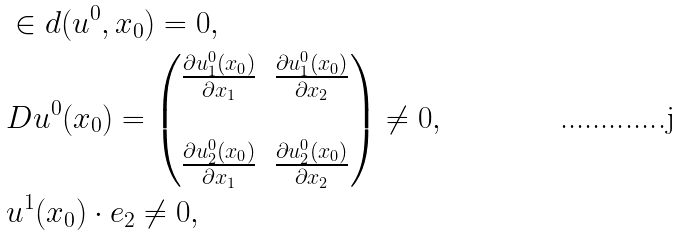<formula> <loc_0><loc_0><loc_500><loc_500>& \in d ( u ^ { 0 } , x _ { 0 } ) = 0 , \\ & D u ^ { 0 } ( x _ { 0 } ) = \left ( \begin{matrix} \frac { \partial u ^ { 0 } _ { 1 } ( x _ { 0 } ) } { \partial x _ { 1 } } & \frac { \partial u ^ { 0 } _ { 1 } ( x _ { 0 } ) } { \partial x _ { 2 } } \\ & \\ \frac { \partial u ^ { 0 } _ { 2 } ( x _ { 0 } ) } { \partial x _ { 1 } } & \frac { \partial u ^ { 0 } _ { 2 } ( x _ { 0 } ) } { \partial x _ { 2 } } \end{matrix} \right ) \not = 0 , \\ & u ^ { 1 } ( x _ { 0 } ) \cdot e _ { 2 } \not = 0 ,</formula> 